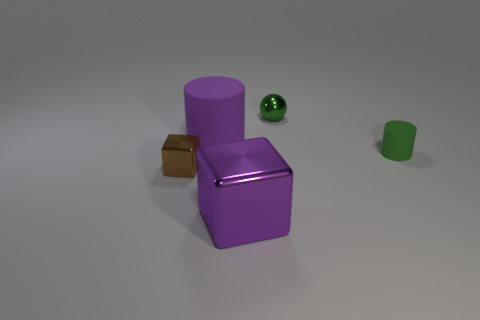Can you describe the lighting and shadows present in the image? The image features soft lighting, with diffuse shadows cast by the objects. The shadow placement indicates that the light source is coming from the upper left side of the scene. 